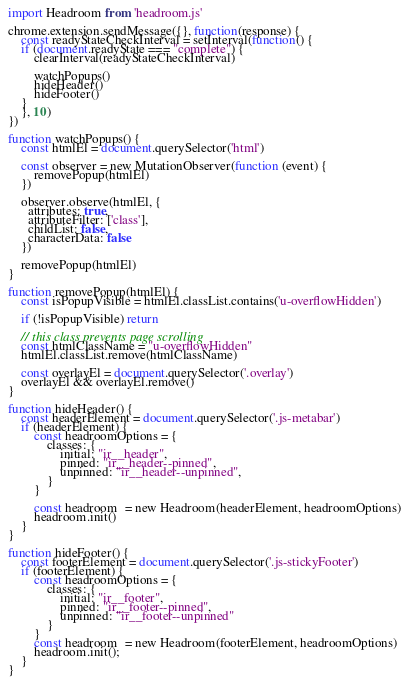<code> <loc_0><loc_0><loc_500><loc_500><_JavaScript_>import Headroom from 'headroom.js'

chrome.extension.sendMessage({}, function(response) {
    const readyStateCheckInterval = setInterval(function() {
    if (document.readyState === "complete") {
        clearInterval(readyStateCheckInterval)

        watchPopups()
        hideHeader()
        hideFooter()
    }
    }, 10)
})

function watchPopups() {
    const htmlEl = document.querySelector('html')
    
    const observer = new MutationObserver(function (event) {
        removePopup(htmlEl)
    })

    observer.observe(htmlEl, {
      attributes: true, 
      attributeFilter: ['class'],
      childList: false, 
      characterData: false
    })

    removePopup(htmlEl)
}

function removePopup(htmlEl) {
    const isPopupVisible = htmlEl.classList.contains('u-overflowHidden')

    if (!isPopupVisible) return

    // this class prevents page scrolling
    const htmlClassName = "u-overflowHidden"
    htmlEl.classList.remove(htmlClassName)

    const overlayEl = document.querySelector('.overlay')
    overlayEl && overlayEl.remove()
}

function hideHeader() {
    const headerElement = document.querySelector('.js-metabar')
    if (headerElement) {
        const headroomOptions = {
            classes: {
                initial: "ir__header",
                pinned: "ir__header--pinned",
                unpinned: "ir__header--unpinned",
            }
        }

        const headroom  = new Headroom(headerElement, headroomOptions)
        headroom.init()
    }
}

function hideFooter() {
    const footerElement = document.querySelector('.js-stickyFooter')
    if (footerElement) {
        const headroomOptions = {
            classes: {
                initial: "ir__footer",
                pinned: "ir__footer--pinned",
                unpinned: "ir__footer--unpinned"
            }
        }
        const headroom  = new Headroom(footerElement, headroomOptions)
        headroom.init();
    }
}
</code> 